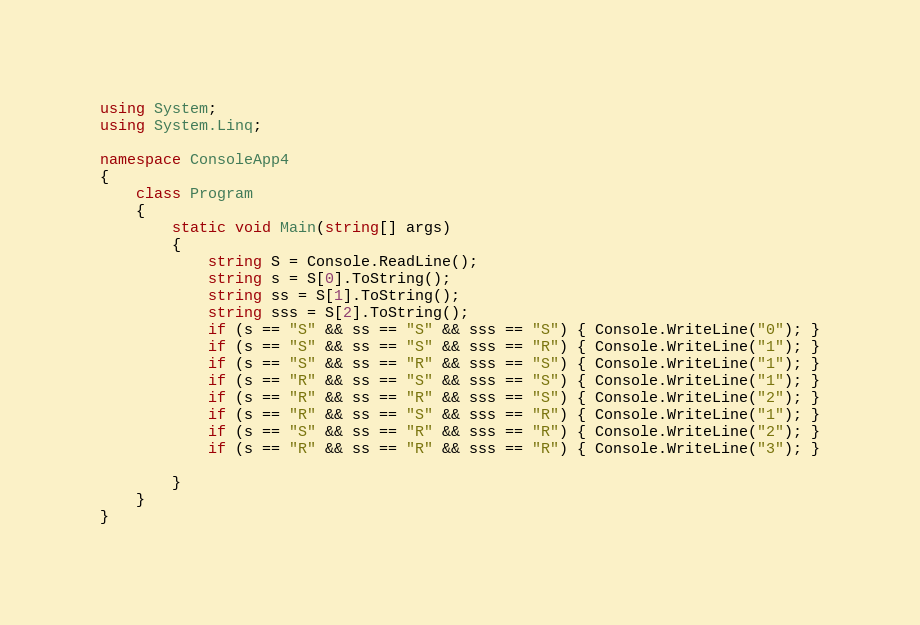<code> <loc_0><loc_0><loc_500><loc_500><_C#_>using System;
using System.Linq;

namespace ConsoleApp4
{
    class Program
    {
        static void Main(string[] args)
        {
            string S = Console.ReadLine();
            string s = S[0].ToString();
            string ss = S[1].ToString();
            string sss = S[2].ToString();
            if (s == "S" && ss == "S" && sss == "S") { Console.WriteLine("0"); }
            if (s == "S" && ss == "S" && sss == "R") { Console.WriteLine("1"); }
            if (s == "S" && ss == "R" && sss == "S") { Console.WriteLine("1"); }
            if (s == "R" && ss == "S" && sss == "S") { Console.WriteLine("1"); }
            if (s == "R" && ss == "R" && sss == "S") { Console.WriteLine("2"); }
            if (s == "R" && ss == "S" && sss == "R") { Console.WriteLine("1"); }
            if (s == "S" && ss == "R" && sss == "R") { Console.WriteLine("2"); }
            if (s == "R" && ss == "R" && sss == "R") { Console.WriteLine("3"); }

        }
    }
}</code> 